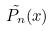<formula> <loc_0><loc_0><loc_500><loc_500>\tilde { P _ { n } } ( x )</formula> 